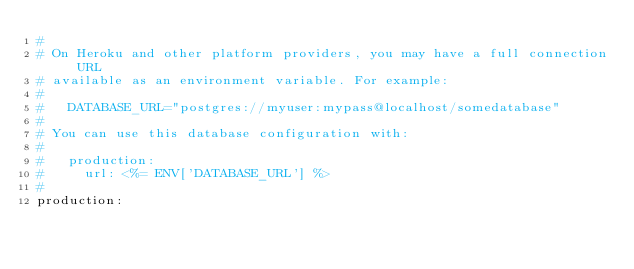<code> <loc_0><loc_0><loc_500><loc_500><_YAML_>#
# On Heroku and other platform providers, you may have a full connection URL
# available as an environment variable. For example:
#
#   DATABASE_URL="postgres://myuser:mypass@localhost/somedatabase"
#
# You can use this database configuration with:
#
#   production:
#     url: <%= ENV['DATABASE_URL'] %>
#
production:</code> 